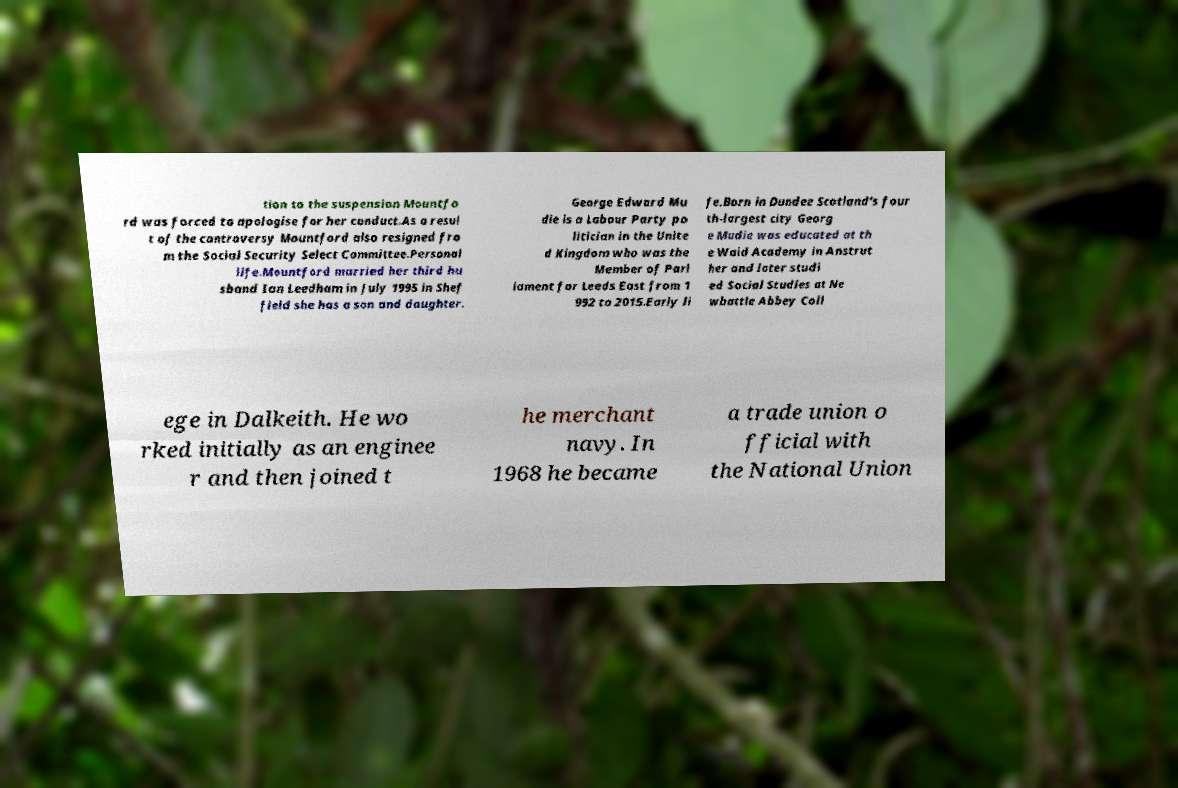Can you read and provide the text displayed in the image?This photo seems to have some interesting text. Can you extract and type it out for me? tion to the suspension Mountfo rd was forced to apologise for her conduct.As a resul t of the controversy Mountford also resigned fro m the Social Security Select Committee.Personal life.Mountford married her third hu sband Ian Leedham in July 1995 in Shef field she has a son and daughter. George Edward Mu die is a Labour Party po litician in the Unite d Kingdom who was the Member of Parl iament for Leeds East from 1 992 to 2015.Early li fe.Born in Dundee Scotland's four th-largest city Georg e Mudie was educated at th e Waid Academy in Anstrut her and later studi ed Social Studies at Ne wbattle Abbey Coll ege in Dalkeith. He wo rked initially as an enginee r and then joined t he merchant navy. In 1968 he became a trade union o fficial with the National Union 